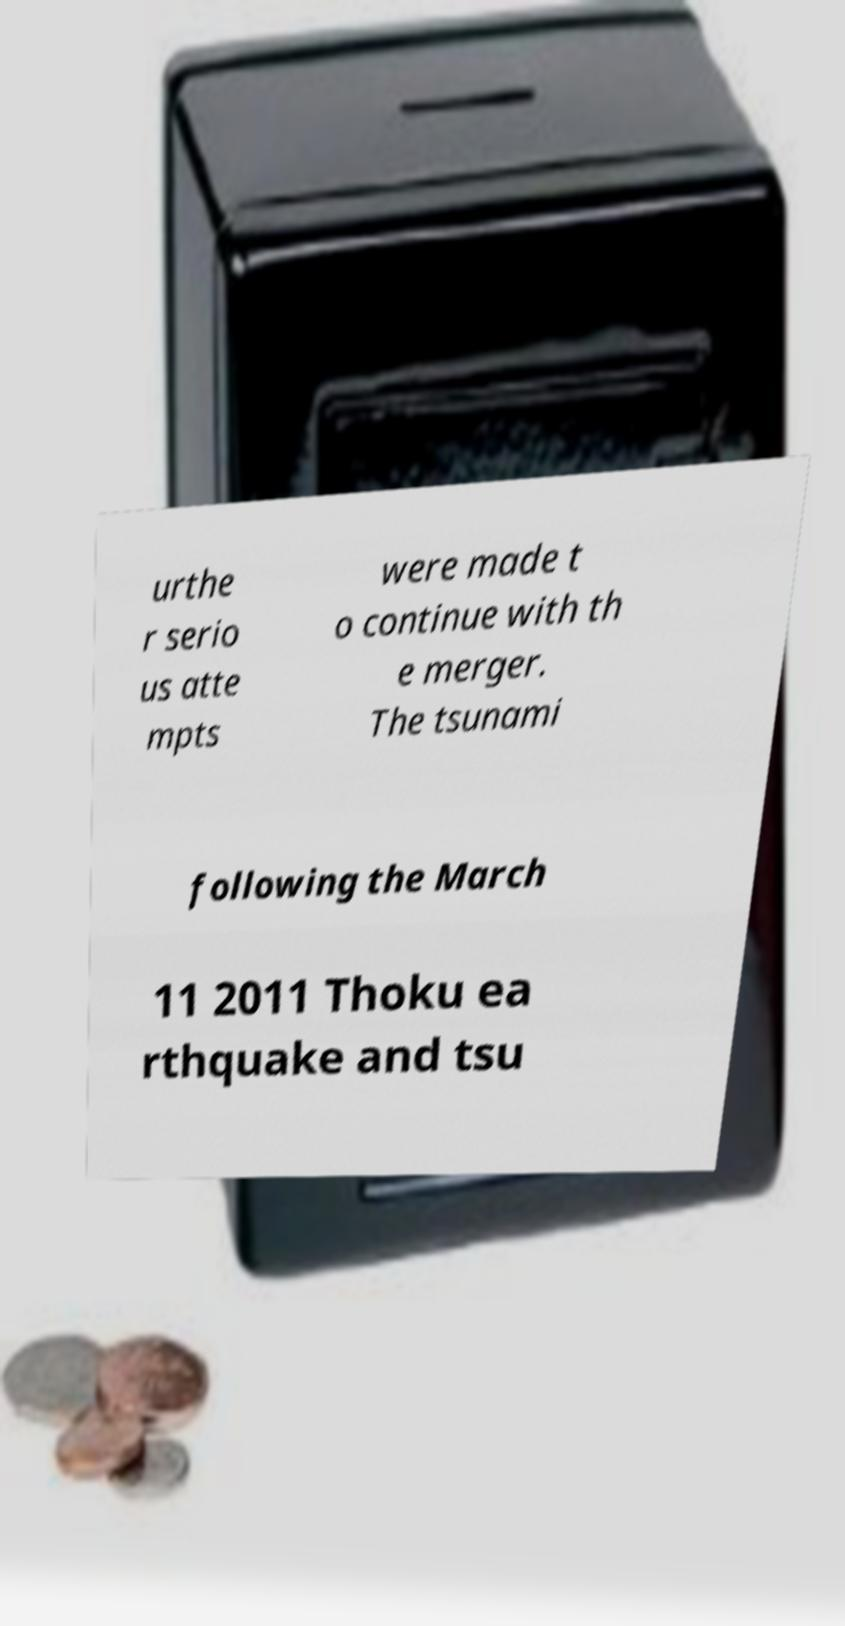What messages or text are displayed in this image? I need them in a readable, typed format. urthe r serio us atte mpts were made t o continue with th e merger. The tsunami following the March 11 2011 Thoku ea rthquake and tsu 